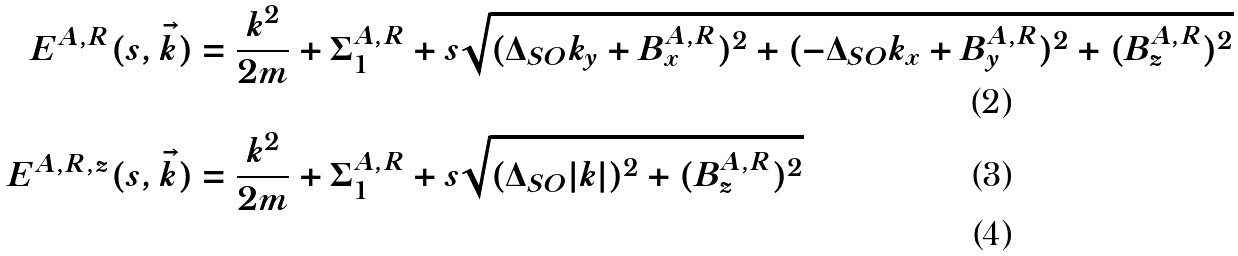<formula> <loc_0><loc_0><loc_500><loc_500>E ^ { A , R } ( s , \vec { k } ) & = \frac { k ^ { 2 } } { 2 m } + \Sigma _ { 1 } ^ { A , R } + s \sqrt { ( \Delta _ { S O } k _ { y } + B _ { x } ^ { A , R } ) ^ { 2 } + ( - \Delta _ { S O } k _ { x } + B _ { y } ^ { A , R } ) ^ { 2 } + ( B _ { z } ^ { A , R } ) ^ { 2 } } \\ E ^ { A , R , z } ( s , \vec { k } ) & = \frac { k ^ { 2 } } { 2 m } + \Sigma _ { 1 } ^ { A , R } + s \sqrt { ( \Delta _ { S O } | k | ) ^ { 2 } + ( B _ { z } ^ { A , R } ) ^ { 2 } } \\</formula> 